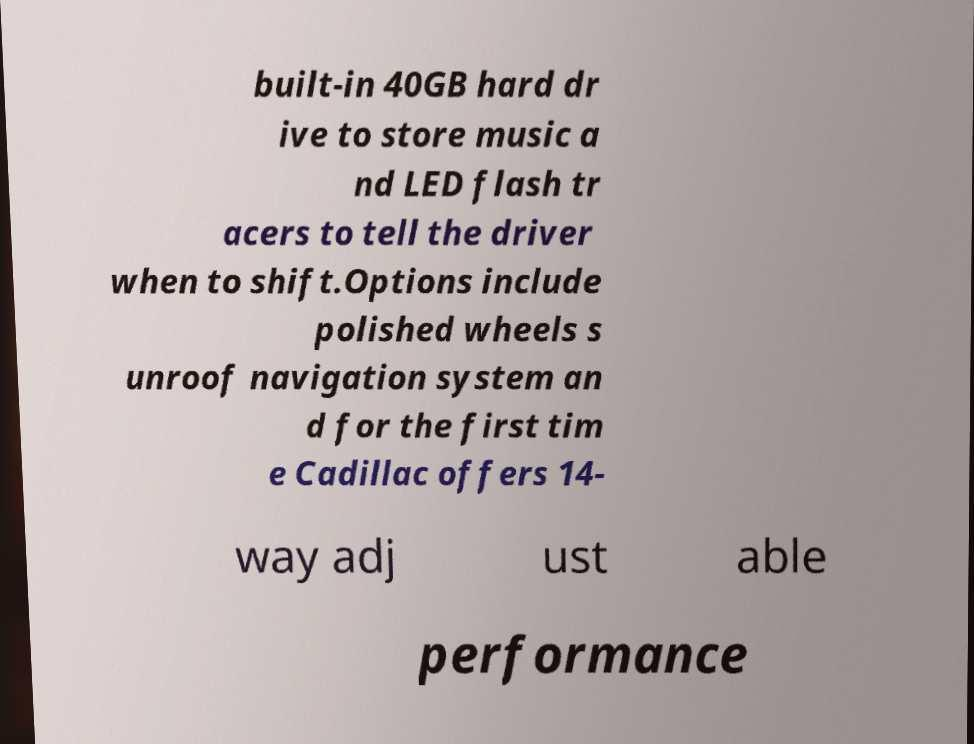Could you assist in decoding the text presented in this image and type it out clearly? built-in 40GB hard dr ive to store music a nd LED flash tr acers to tell the driver when to shift.Options include polished wheels s unroof navigation system an d for the first tim e Cadillac offers 14- way adj ust able performance 